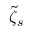<formula> <loc_0><loc_0><loc_500><loc_500>\tilde { \zeta } _ { s }</formula> 